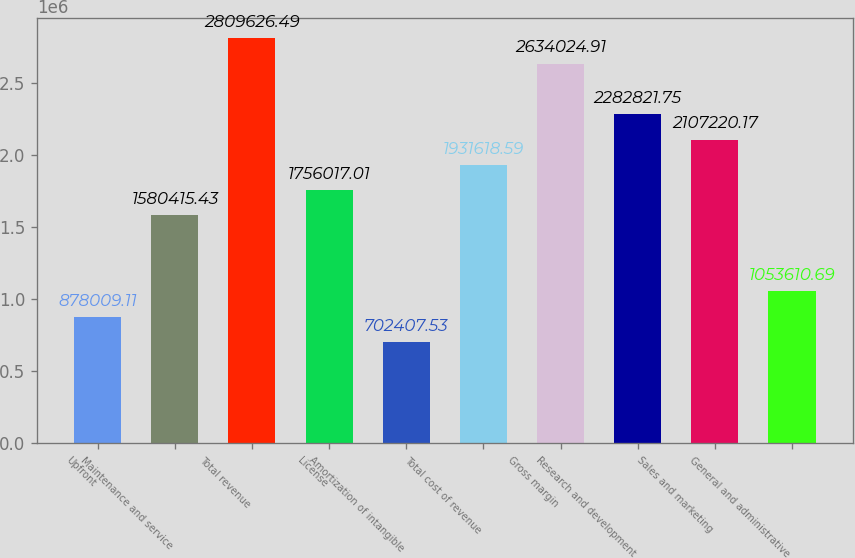Convert chart. <chart><loc_0><loc_0><loc_500><loc_500><bar_chart><fcel>Upfront<fcel>Maintenance and service<fcel>Total revenue<fcel>License<fcel>Amortization of intangible<fcel>Total cost of revenue<fcel>Gross margin<fcel>Research and development<fcel>Sales and marketing<fcel>General and administrative<nl><fcel>878009<fcel>1.58042e+06<fcel>2.80963e+06<fcel>1.75602e+06<fcel>702408<fcel>1.93162e+06<fcel>2.63402e+06<fcel>2.28282e+06<fcel>2.10722e+06<fcel>1.05361e+06<nl></chart> 